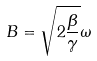Convert formula to latex. <formula><loc_0><loc_0><loc_500><loc_500>B = \sqrt { 2 \frac { \beta } { \gamma } } { \omega }</formula> 